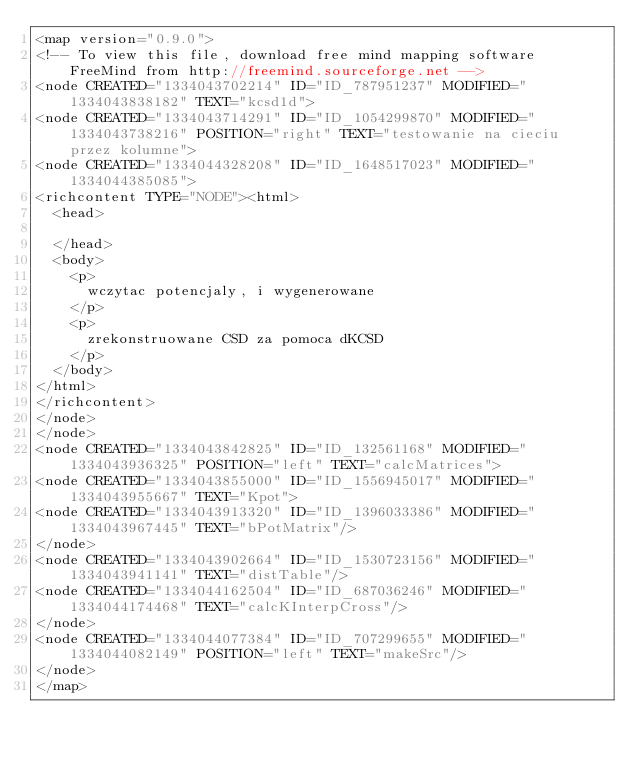Convert code to text. <code><loc_0><loc_0><loc_500><loc_500><_ObjectiveC_><map version="0.9.0">
<!-- To view this file, download free mind mapping software FreeMind from http://freemind.sourceforge.net -->
<node CREATED="1334043702214" ID="ID_787951237" MODIFIED="1334043838182" TEXT="kcsd1d">
<node CREATED="1334043714291" ID="ID_1054299870" MODIFIED="1334043738216" POSITION="right" TEXT="testowanie na cieciu przez kolumne">
<node CREATED="1334044328208" ID="ID_1648517023" MODIFIED="1334044385085">
<richcontent TYPE="NODE"><html>
  <head>
    
  </head>
  <body>
    <p>
      wczytac potencjaly, i wygenerowane
    </p>
    <p>
      zrekonstruowane CSD za pomoca dKCSD
    </p>
  </body>
</html>
</richcontent>
</node>
</node>
<node CREATED="1334043842825" ID="ID_132561168" MODIFIED="1334043936325" POSITION="left" TEXT="calcMatrices">
<node CREATED="1334043855000" ID="ID_1556945017" MODIFIED="1334043955667" TEXT="Kpot">
<node CREATED="1334043913320" ID="ID_1396033386" MODIFIED="1334043967445" TEXT="bPotMatrix"/>
</node>
<node CREATED="1334043902664" ID="ID_1530723156" MODIFIED="1334043941141" TEXT="distTable"/>
<node CREATED="1334044162504" ID="ID_687036246" MODIFIED="1334044174468" TEXT="calcKInterpCross"/>
</node>
<node CREATED="1334044077384" ID="ID_707299655" MODIFIED="1334044082149" POSITION="left" TEXT="makeSrc"/>
</node>
</map>
</code> 